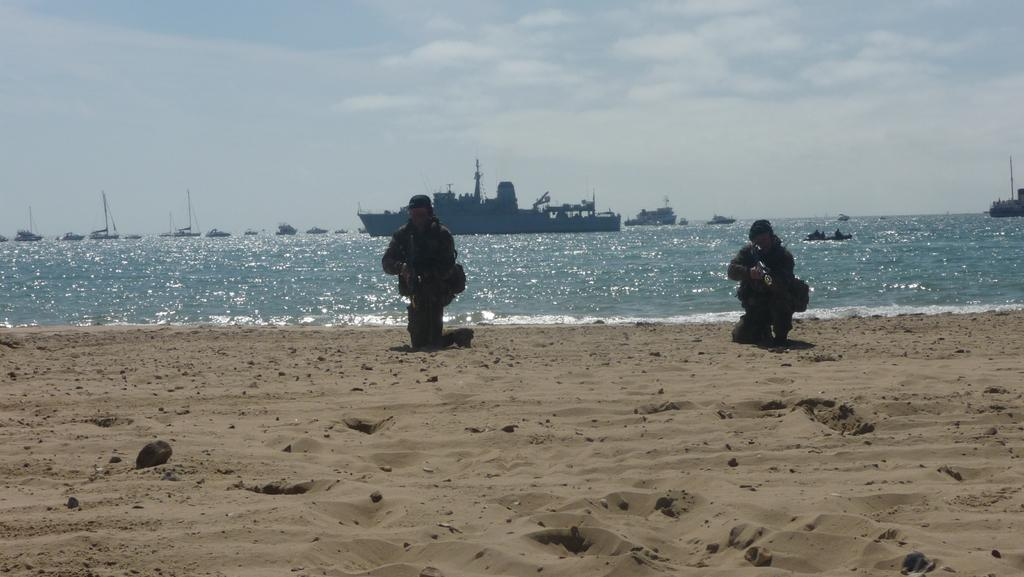What type of terrain is depicted in the image? There is sand in the image, which suggests a beach or coastal area. What natural element is present alongside the sand? There is water in the image, which is typical for a beach or coastal area. What can be seen in the sky in the image? Clouds and the sky are visible in the image. What type of watercraft can be seen in the water? There are boats and a ship in the water. How many people are present in the image? There are two persons in the image. What word is being spelled out by the sand in the image? There is no word being spelled out by the sand in the image. What type of tray is being used by the persons in the image? There is no tray present in the image. 